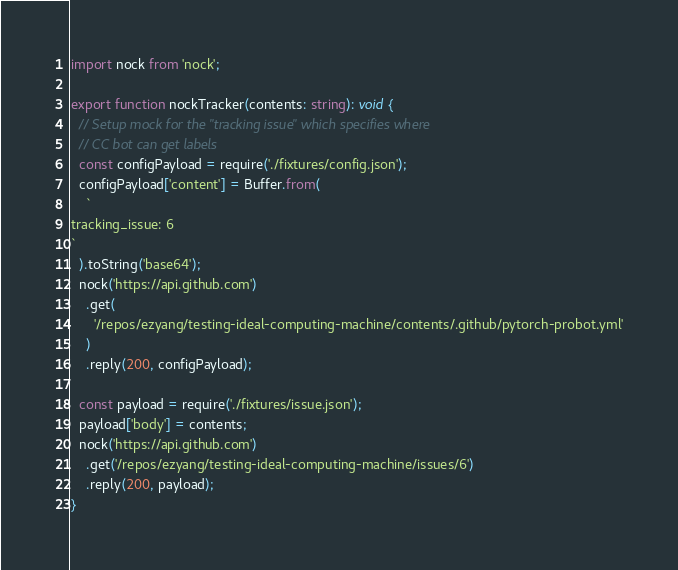Convert code to text. <code><loc_0><loc_0><loc_500><loc_500><_TypeScript_>import nock from 'nock';

export function nockTracker(contents: string): void {
  // Setup mock for the "tracking issue" which specifies where
  // CC bot can get labels
  const configPayload = require('./fixtures/config.json');
  configPayload['content'] = Buffer.from(
    `
tracking_issue: 6
`
  ).toString('base64');
  nock('https://api.github.com')
    .get(
      '/repos/ezyang/testing-ideal-computing-machine/contents/.github/pytorch-probot.yml'
    )
    .reply(200, configPayload);

  const payload = require('./fixtures/issue.json');
  payload['body'] = contents;
  nock('https://api.github.com')
    .get('/repos/ezyang/testing-ideal-computing-machine/issues/6')
    .reply(200, payload);
}
</code> 